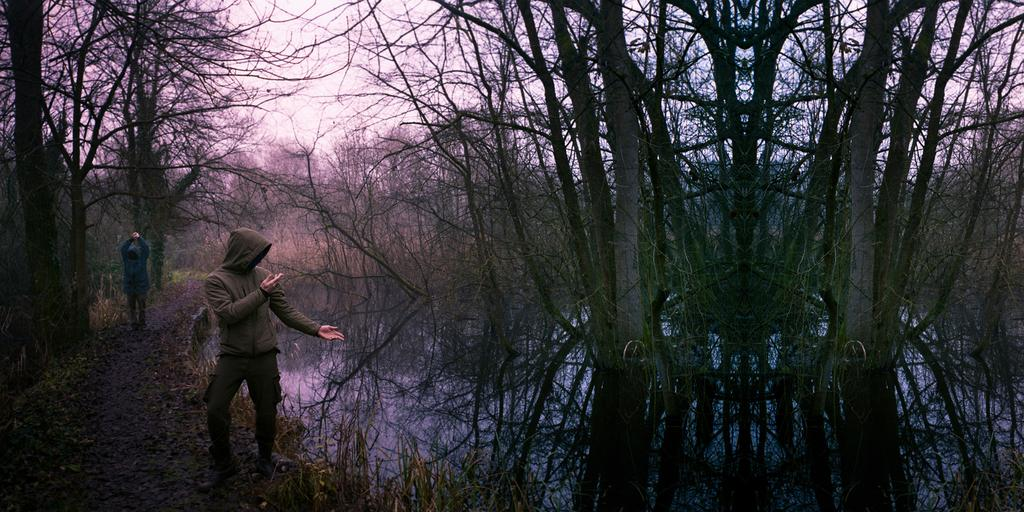What type of vegetation can be seen in the image? There are trees in the image. Where are the two persons located in the image? The two persons are standing on the left side of the image. What is in the middle of the image? There is water in the middle of the image. What is visible at the top of the image? The sky is visible at the top of the image. What type of scent can be detected from the trees in the image? There is no information about the scent of the trees in the image, as we are only given visual information. 